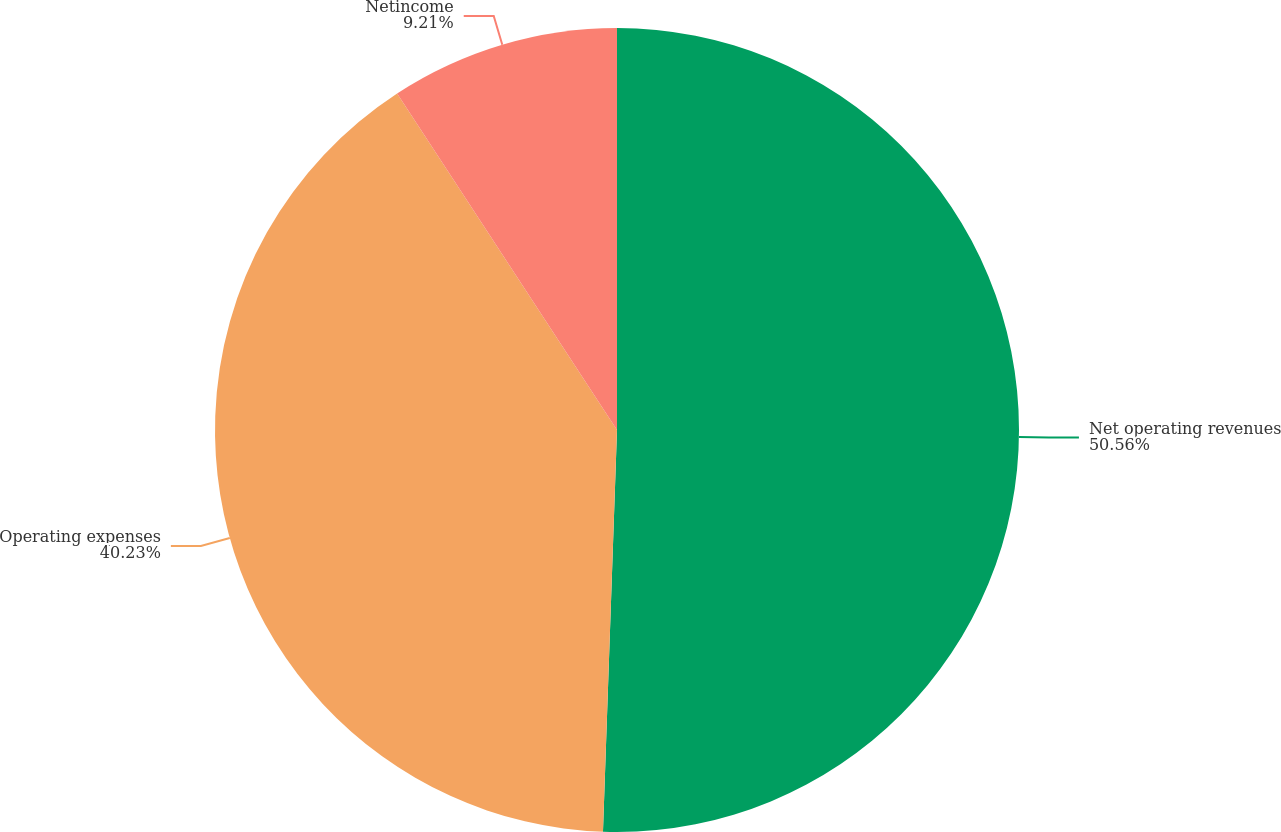Convert chart to OTSL. <chart><loc_0><loc_0><loc_500><loc_500><pie_chart><fcel>Net operating revenues<fcel>Operating expenses<fcel>Netincome<nl><fcel>50.55%<fcel>40.23%<fcel>9.21%<nl></chart> 